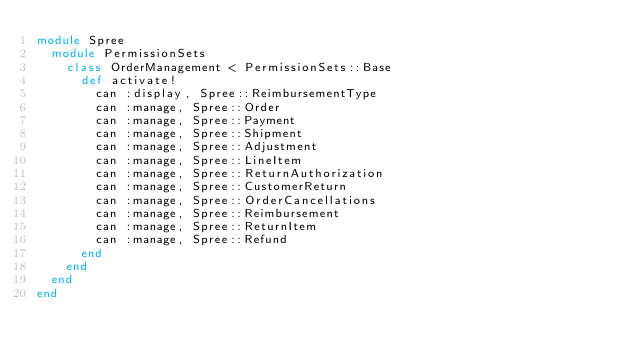<code> <loc_0><loc_0><loc_500><loc_500><_Ruby_>module Spree
  module PermissionSets
    class OrderManagement < PermissionSets::Base
      def activate!
        can :display, Spree::ReimbursementType
        can :manage, Spree::Order
        can :manage, Spree::Payment
        can :manage, Spree::Shipment
        can :manage, Spree::Adjustment
        can :manage, Spree::LineItem
        can :manage, Spree::ReturnAuthorization
        can :manage, Spree::CustomerReturn
        can :manage, Spree::OrderCancellations
        can :manage, Spree::Reimbursement
        can :manage, Spree::ReturnItem
        can :manage, Spree::Refund
      end
    end
  end
end
</code> 